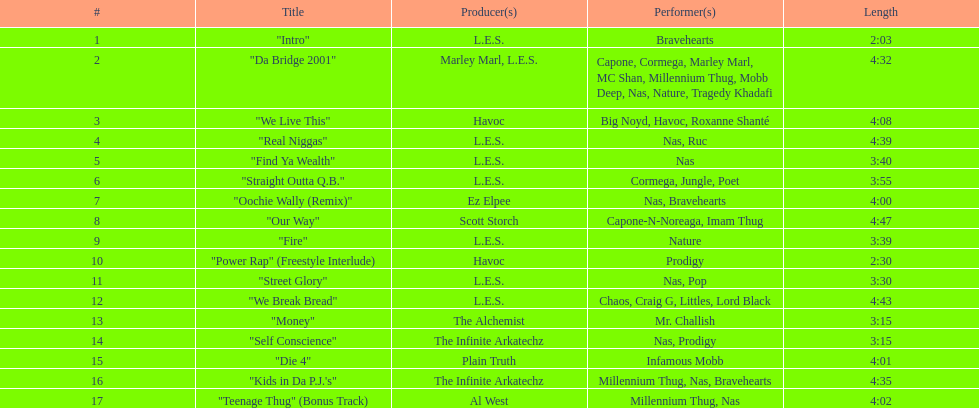How many minutes does the shortest song on the album last? 2:03. 